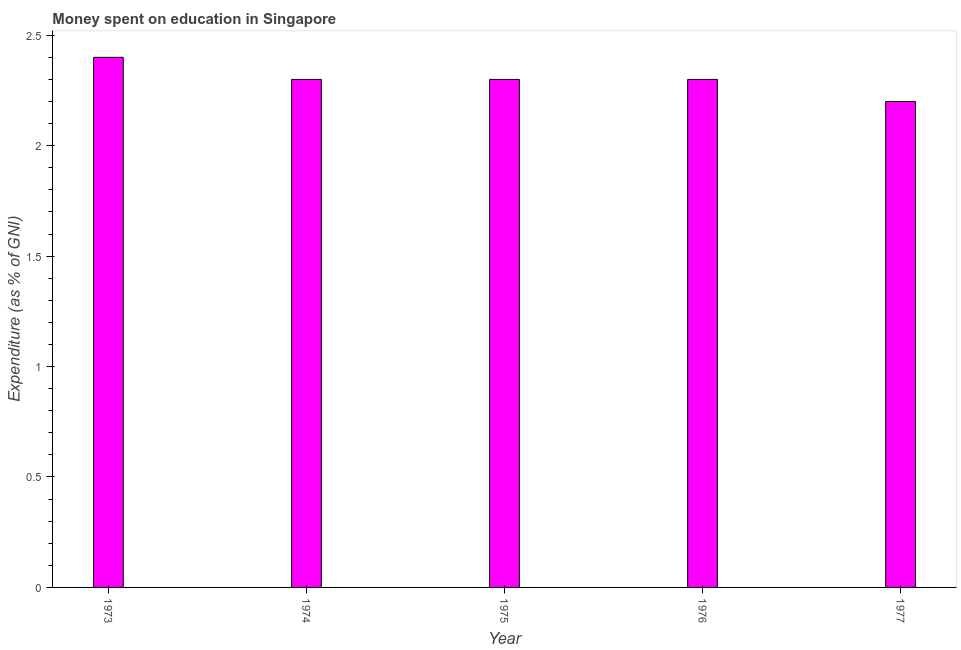Does the graph contain any zero values?
Your answer should be very brief. No. What is the title of the graph?
Give a very brief answer. Money spent on education in Singapore. What is the label or title of the X-axis?
Make the answer very short. Year. What is the label or title of the Y-axis?
Your answer should be very brief. Expenditure (as % of GNI). What is the expenditure on education in 1973?
Offer a very short reply. 2.4. In which year was the expenditure on education minimum?
Offer a terse response. 1977. What is the sum of the expenditure on education?
Offer a very short reply. 11.5. What is the ratio of the expenditure on education in 1973 to that in 1976?
Offer a very short reply. 1.04. What is the difference between the highest and the lowest expenditure on education?
Your answer should be very brief. 0.2. In how many years, is the expenditure on education greater than the average expenditure on education taken over all years?
Provide a succinct answer. 1. How many bars are there?
Your response must be concise. 5. How many years are there in the graph?
Ensure brevity in your answer.  5. What is the difference between two consecutive major ticks on the Y-axis?
Your answer should be very brief. 0.5. Are the values on the major ticks of Y-axis written in scientific E-notation?
Your answer should be compact. No. What is the Expenditure (as % of GNI) in 1974?
Keep it short and to the point. 2.3. What is the Expenditure (as % of GNI) of 1975?
Ensure brevity in your answer.  2.3. What is the Expenditure (as % of GNI) in 1976?
Ensure brevity in your answer.  2.3. What is the Expenditure (as % of GNI) of 1977?
Make the answer very short. 2.2. What is the difference between the Expenditure (as % of GNI) in 1973 and 1975?
Your response must be concise. 0.1. What is the difference between the Expenditure (as % of GNI) in 1973 and 1976?
Provide a short and direct response. 0.1. What is the difference between the Expenditure (as % of GNI) in 1974 and 1975?
Your answer should be compact. 0. What is the difference between the Expenditure (as % of GNI) in 1974 and 1976?
Make the answer very short. 0. What is the difference between the Expenditure (as % of GNI) in 1974 and 1977?
Give a very brief answer. 0.1. What is the difference between the Expenditure (as % of GNI) in 1975 and 1976?
Give a very brief answer. 0. What is the difference between the Expenditure (as % of GNI) in 1975 and 1977?
Provide a short and direct response. 0.1. What is the ratio of the Expenditure (as % of GNI) in 1973 to that in 1974?
Offer a terse response. 1.04. What is the ratio of the Expenditure (as % of GNI) in 1973 to that in 1975?
Your answer should be very brief. 1.04. What is the ratio of the Expenditure (as % of GNI) in 1973 to that in 1976?
Your answer should be compact. 1.04. What is the ratio of the Expenditure (as % of GNI) in 1973 to that in 1977?
Ensure brevity in your answer.  1.09. What is the ratio of the Expenditure (as % of GNI) in 1974 to that in 1976?
Keep it short and to the point. 1. What is the ratio of the Expenditure (as % of GNI) in 1974 to that in 1977?
Make the answer very short. 1.04. What is the ratio of the Expenditure (as % of GNI) in 1975 to that in 1976?
Give a very brief answer. 1. What is the ratio of the Expenditure (as % of GNI) in 1975 to that in 1977?
Give a very brief answer. 1.04. What is the ratio of the Expenditure (as % of GNI) in 1976 to that in 1977?
Give a very brief answer. 1.04. 